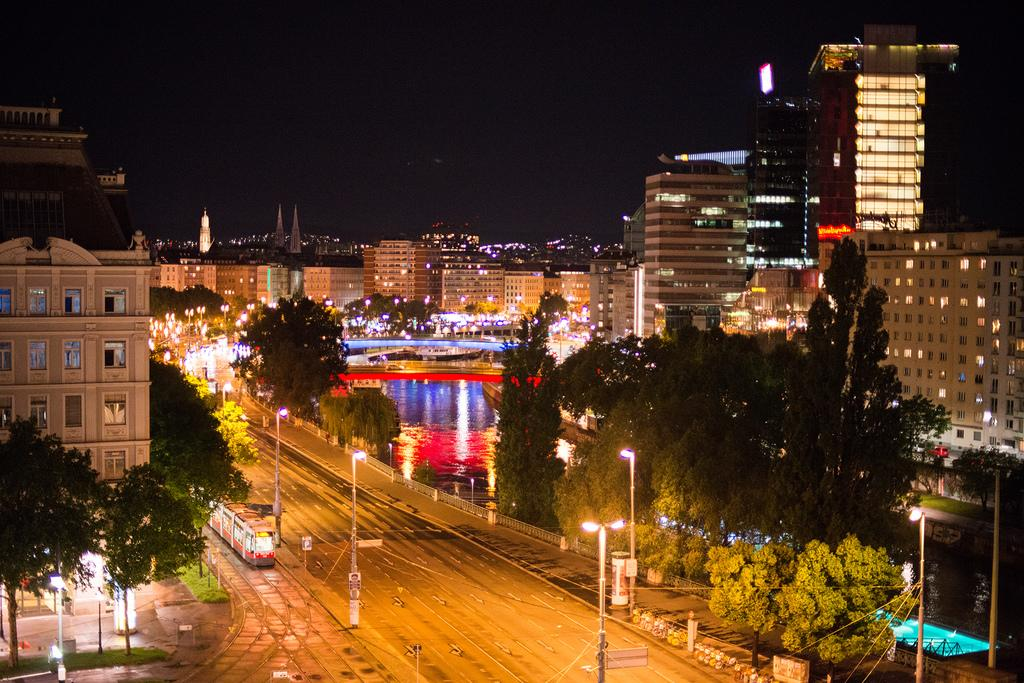What is the main subject of the image? The main subject of the image is a train moving on the left side. What can be seen on either side of the train? There are trees on either side of the image. What other structures are visible in the image? There are buildings in the image. What is in the middle of the image? There is a pond in the middle of the image. What is visible at the top of the image? The sky is visible at the top of the image. What type of vest is the stranger wearing in the image? There is no stranger present in the image, so it is not possible to determine what type of vest they might be wearing. 